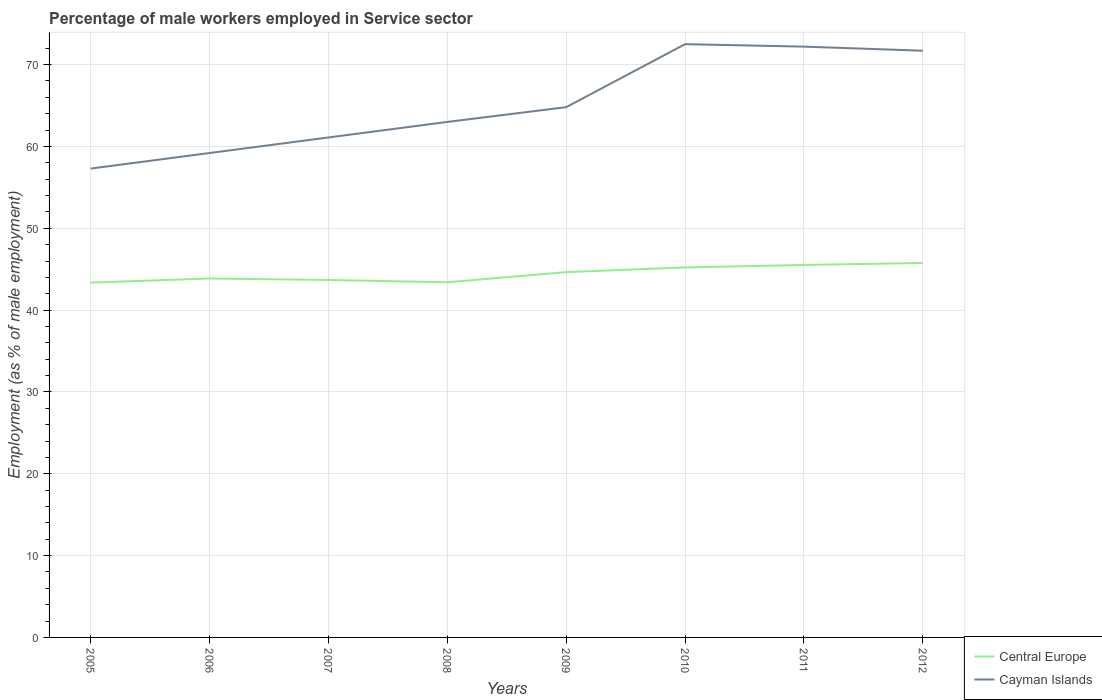How many different coloured lines are there?
Offer a terse response. 2. Does the line corresponding to Cayman Islands intersect with the line corresponding to Central Europe?
Make the answer very short. No. Is the number of lines equal to the number of legend labels?
Provide a succinct answer. Yes. Across all years, what is the maximum percentage of male workers employed in Service sector in Central Europe?
Ensure brevity in your answer.  43.36. What is the total percentage of male workers employed in Service sector in Cayman Islands in the graph?
Provide a short and direct response. -14.4. What is the difference between the highest and the second highest percentage of male workers employed in Service sector in Central Europe?
Offer a terse response. 2.4. Is the percentage of male workers employed in Service sector in Central Europe strictly greater than the percentage of male workers employed in Service sector in Cayman Islands over the years?
Offer a very short reply. Yes. How many years are there in the graph?
Your answer should be very brief. 8. Are the values on the major ticks of Y-axis written in scientific E-notation?
Give a very brief answer. No. How many legend labels are there?
Offer a terse response. 2. What is the title of the graph?
Offer a terse response. Percentage of male workers employed in Service sector. Does "Nepal" appear as one of the legend labels in the graph?
Your answer should be very brief. No. What is the label or title of the X-axis?
Make the answer very short. Years. What is the label or title of the Y-axis?
Offer a very short reply. Employment (as % of male employment). What is the Employment (as % of male employment) in Central Europe in 2005?
Keep it short and to the point. 43.36. What is the Employment (as % of male employment) of Cayman Islands in 2005?
Your response must be concise. 57.3. What is the Employment (as % of male employment) of Central Europe in 2006?
Provide a short and direct response. 43.87. What is the Employment (as % of male employment) in Cayman Islands in 2006?
Provide a succinct answer. 59.2. What is the Employment (as % of male employment) of Central Europe in 2007?
Offer a very short reply. 43.68. What is the Employment (as % of male employment) of Cayman Islands in 2007?
Keep it short and to the point. 61.1. What is the Employment (as % of male employment) of Central Europe in 2008?
Keep it short and to the point. 43.4. What is the Employment (as % of male employment) of Central Europe in 2009?
Your answer should be very brief. 44.64. What is the Employment (as % of male employment) in Cayman Islands in 2009?
Provide a short and direct response. 64.8. What is the Employment (as % of male employment) of Central Europe in 2010?
Your answer should be compact. 45.22. What is the Employment (as % of male employment) in Cayman Islands in 2010?
Provide a short and direct response. 72.5. What is the Employment (as % of male employment) in Central Europe in 2011?
Offer a terse response. 45.52. What is the Employment (as % of male employment) in Cayman Islands in 2011?
Give a very brief answer. 72.2. What is the Employment (as % of male employment) in Central Europe in 2012?
Your answer should be very brief. 45.76. What is the Employment (as % of male employment) in Cayman Islands in 2012?
Offer a terse response. 71.7. Across all years, what is the maximum Employment (as % of male employment) in Central Europe?
Give a very brief answer. 45.76. Across all years, what is the maximum Employment (as % of male employment) of Cayman Islands?
Your response must be concise. 72.5. Across all years, what is the minimum Employment (as % of male employment) in Central Europe?
Give a very brief answer. 43.36. Across all years, what is the minimum Employment (as % of male employment) in Cayman Islands?
Offer a very short reply. 57.3. What is the total Employment (as % of male employment) of Central Europe in the graph?
Your answer should be very brief. 355.45. What is the total Employment (as % of male employment) of Cayman Islands in the graph?
Your answer should be very brief. 521.8. What is the difference between the Employment (as % of male employment) of Central Europe in 2005 and that in 2006?
Your answer should be very brief. -0.51. What is the difference between the Employment (as % of male employment) of Central Europe in 2005 and that in 2007?
Provide a succinct answer. -0.33. What is the difference between the Employment (as % of male employment) of Central Europe in 2005 and that in 2008?
Ensure brevity in your answer.  -0.04. What is the difference between the Employment (as % of male employment) in Central Europe in 2005 and that in 2009?
Provide a succinct answer. -1.28. What is the difference between the Employment (as % of male employment) in Central Europe in 2005 and that in 2010?
Offer a terse response. -1.86. What is the difference between the Employment (as % of male employment) of Cayman Islands in 2005 and that in 2010?
Your answer should be compact. -15.2. What is the difference between the Employment (as % of male employment) in Central Europe in 2005 and that in 2011?
Your answer should be compact. -2.16. What is the difference between the Employment (as % of male employment) of Cayman Islands in 2005 and that in 2011?
Your answer should be very brief. -14.9. What is the difference between the Employment (as % of male employment) in Central Europe in 2005 and that in 2012?
Offer a very short reply. -2.4. What is the difference between the Employment (as % of male employment) in Cayman Islands in 2005 and that in 2012?
Ensure brevity in your answer.  -14.4. What is the difference between the Employment (as % of male employment) of Central Europe in 2006 and that in 2007?
Offer a terse response. 0.18. What is the difference between the Employment (as % of male employment) in Cayman Islands in 2006 and that in 2007?
Keep it short and to the point. -1.9. What is the difference between the Employment (as % of male employment) of Central Europe in 2006 and that in 2008?
Your answer should be compact. 0.46. What is the difference between the Employment (as % of male employment) in Central Europe in 2006 and that in 2009?
Your answer should be very brief. -0.78. What is the difference between the Employment (as % of male employment) of Cayman Islands in 2006 and that in 2009?
Offer a very short reply. -5.6. What is the difference between the Employment (as % of male employment) in Central Europe in 2006 and that in 2010?
Keep it short and to the point. -1.35. What is the difference between the Employment (as % of male employment) in Central Europe in 2006 and that in 2011?
Offer a very short reply. -1.65. What is the difference between the Employment (as % of male employment) in Cayman Islands in 2006 and that in 2011?
Your answer should be compact. -13. What is the difference between the Employment (as % of male employment) of Central Europe in 2006 and that in 2012?
Provide a short and direct response. -1.89. What is the difference between the Employment (as % of male employment) of Cayman Islands in 2006 and that in 2012?
Provide a short and direct response. -12.5. What is the difference between the Employment (as % of male employment) of Central Europe in 2007 and that in 2008?
Make the answer very short. 0.28. What is the difference between the Employment (as % of male employment) of Cayman Islands in 2007 and that in 2008?
Provide a succinct answer. -1.9. What is the difference between the Employment (as % of male employment) of Central Europe in 2007 and that in 2009?
Provide a short and direct response. -0.96. What is the difference between the Employment (as % of male employment) in Central Europe in 2007 and that in 2010?
Your answer should be very brief. -1.53. What is the difference between the Employment (as % of male employment) in Cayman Islands in 2007 and that in 2010?
Provide a short and direct response. -11.4. What is the difference between the Employment (as % of male employment) of Central Europe in 2007 and that in 2011?
Ensure brevity in your answer.  -1.84. What is the difference between the Employment (as % of male employment) of Cayman Islands in 2007 and that in 2011?
Your answer should be compact. -11.1. What is the difference between the Employment (as % of male employment) in Central Europe in 2007 and that in 2012?
Offer a very short reply. -2.08. What is the difference between the Employment (as % of male employment) of Central Europe in 2008 and that in 2009?
Offer a terse response. -1.24. What is the difference between the Employment (as % of male employment) in Cayman Islands in 2008 and that in 2009?
Offer a very short reply. -1.8. What is the difference between the Employment (as % of male employment) in Central Europe in 2008 and that in 2010?
Give a very brief answer. -1.81. What is the difference between the Employment (as % of male employment) of Cayman Islands in 2008 and that in 2010?
Ensure brevity in your answer.  -9.5. What is the difference between the Employment (as % of male employment) in Central Europe in 2008 and that in 2011?
Make the answer very short. -2.12. What is the difference between the Employment (as % of male employment) in Central Europe in 2008 and that in 2012?
Keep it short and to the point. -2.36. What is the difference between the Employment (as % of male employment) in Cayman Islands in 2008 and that in 2012?
Make the answer very short. -8.7. What is the difference between the Employment (as % of male employment) of Central Europe in 2009 and that in 2010?
Keep it short and to the point. -0.57. What is the difference between the Employment (as % of male employment) in Cayman Islands in 2009 and that in 2010?
Provide a short and direct response. -7.7. What is the difference between the Employment (as % of male employment) of Central Europe in 2009 and that in 2011?
Give a very brief answer. -0.88. What is the difference between the Employment (as % of male employment) in Cayman Islands in 2009 and that in 2011?
Ensure brevity in your answer.  -7.4. What is the difference between the Employment (as % of male employment) in Central Europe in 2009 and that in 2012?
Make the answer very short. -1.12. What is the difference between the Employment (as % of male employment) in Cayman Islands in 2009 and that in 2012?
Your response must be concise. -6.9. What is the difference between the Employment (as % of male employment) in Central Europe in 2010 and that in 2011?
Your response must be concise. -0.3. What is the difference between the Employment (as % of male employment) of Cayman Islands in 2010 and that in 2011?
Ensure brevity in your answer.  0.3. What is the difference between the Employment (as % of male employment) in Central Europe in 2010 and that in 2012?
Offer a terse response. -0.54. What is the difference between the Employment (as % of male employment) in Cayman Islands in 2010 and that in 2012?
Offer a very short reply. 0.8. What is the difference between the Employment (as % of male employment) of Central Europe in 2011 and that in 2012?
Provide a succinct answer. -0.24. What is the difference between the Employment (as % of male employment) in Central Europe in 2005 and the Employment (as % of male employment) in Cayman Islands in 2006?
Offer a terse response. -15.84. What is the difference between the Employment (as % of male employment) in Central Europe in 2005 and the Employment (as % of male employment) in Cayman Islands in 2007?
Provide a succinct answer. -17.74. What is the difference between the Employment (as % of male employment) in Central Europe in 2005 and the Employment (as % of male employment) in Cayman Islands in 2008?
Offer a terse response. -19.64. What is the difference between the Employment (as % of male employment) in Central Europe in 2005 and the Employment (as % of male employment) in Cayman Islands in 2009?
Provide a succinct answer. -21.44. What is the difference between the Employment (as % of male employment) in Central Europe in 2005 and the Employment (as % of male employment) in Cayman Islands in 2010?
Provide a short and direct response. -29.14. What is the difference between the Employment (as % of male employment) in Central Europe in 2005 and the Employment (as % of male employment) in Cayman Islands in 2011?
Your answer should be very brief. -28.84. What is the difference between the Employment (as % of male employment) of Central Europe in 2005 and the Employment (as % of male employment) of Cayman Islands in 2012?
Your response must be concise. -28.34. What is the difference between the Employment (as % of male employment) of Central Europe in 2006 and the Employment (as % of male employment) of Cayman Islands in 2007?
Provide a succinct answer. -17.23. What is the difference between the Employment (as % of male employment) in Central Europe in 2006 and the Employment (as % of male employment) in Cayman Islands in 2008?
Provide a short and direct response. -19.13. What is the difference between the Employment (as % of male employment) of Central Europe in 2006 and the Employment (as % of male employment) of Cayman Islands in 2009?
Make the answer very short. -20.93. What is the difference between the Employment (as % of male employment) in Central Europe in 2006 and the Employment (as % of male employment) in Cayman Islands in 2010?
Make the answer very short. -28.63. What is the difference between the Employment (as % of male employment) of Central Europe in 2006 and the Employment (as % of male employment) of Cayman Islands in 2011?
Your answer should be compact. -28.33. What is the difference between the Employment (as % of male employment) of Central Europe in 2006 and the Employment (as % of male employment) of Cayman Islands in 2012?
Your answer should be compact. -27.83. What is the difference between the Employment (as % of male employment) of Central Europe in 2007 and the Employment (as % of male employment) of Cayman Islands in 2008?
Provide a succinct answer. -19.32. What is the difference between the Employment (as % of male employment) in Central Europe in 2007 and the Employment (as % of male employment) in Cayman Islands in 2009?
Give a very brief answer. -21.12. What is the difference between the Employment (as % of male employment) of Central Europe in 2007 and the Employment (as % of male employment) of Cayman Islands in 2010?
Offer a terse response. -28.82. What is the difference between the Employment (as % of male employment) of Central Europe in 2007 and the Employment (as % of male employment) of Cayman Islands in 2011?
Offer a very short reply. -28.52. What is the difference between the Employment (as % of male employment) in Central Europe in 2007 and the Employment (as % of male employment) in Cayman Islands in 2012?
Provide a succinct answer. -28.02. What is the difference between the Employment (as % of male employment) of Central Europe in 2008 and the Employment (as % of male employment) of Cayman Islands in 2009?
Ensure brevity in your answer.  -21.4. What is the difference between the Employment (as % of male employment) of Central Europe in 2008 and the Employment (as % of male employment) of Cayman Islands in 2010?
Your response must be concise. -29.1. What is the difference between the Employment (as % of male employment) of Central Europe in 2008 and the Employment (as % of male employment) of Cayman Islands in 2011?
Your answer should be very brief. -28.8. What is the difference between the Employment (as % of male employment) of Central Europe in 2008 and the Employment (as % of male employment) of Cayman Islands in 2012?
Give a very brief answer. -28.3. What is the difference between the Employment (as % of male employment) of Central Europe in 2009 and the Employment (as % of male employment) of Cayman Islands in 2010?
Your answer should be very brief. -27.86. What is the difference between the Employment (as % of male employment) in Central Europe in 2009 and the Employment (as % of male employment) in Cayman Islands in 2011?
Your answer should be compact. -27.56. What is the difference between the Employment (as % of male employment) in Central Europe in 2009 and the Employment (as % of male employment) in Cayman Islands in 2012?
Offer a terse response. -27.06. What is the difference between the Employment (as % of male employment) in Central Europe in 2010 and the Employment (as % of male employment) in Cayman Islands in 2011?
Offer a very short reply. -26.98. What is the difference between the Employment (as % of male employment) of Central Europe in 2010 and the Employment (as % of male employment) of Cayman Islands in 2012?
Keep it short and to the point. -26.48. What is the difference between the Employment (as % of male employment) of Central Europe in 2011 and the Employment (as % of male employment) of Cayman Islands in 2012?
Give a very brief answer. -26.18. What is the average Employment (as % of male employment) in Central Europe per year?
Your answer should be compact. 44.43. What is the average Employment (as % of male employment) of Cayman Islands per year?
Ensure brevity in your answer.  65.22. In the year 2005, what is the difference between the Employment (as % of male employment) of Central Europe and Employment (as % of male employment) of Cayman Islands?
Your answer should be very brief. -13.94. In the year 2006, what is the difference between the Employment (as % of male employment) in Central Europe and Employment (as % of male employment) in Cayman Islands?
Your response must be concise. -15.33. In the year 2007, what is the difference between the Employment (as % of male employment) in Central Europe and Employment (as % of male employment) in Cayman Islands?
Offer a terse response. -17.42. In the year 2008, what is the difference between the Employment (as % of male employment) in Central Europe and Employment (as % of male employment) in Cayman Islands?
Make the answer very short. -19.6. In the year 2009, what is the difference between the Employment (as % of male employment) of Central Europe and Employment (as % of male employment) of Cayman Islands?
Provide a short and direct response. -20.16. In the year 2010, what is the difference between the Employment (as % of male employment) in Central Europe and Employment (as % of male employment) in Cayman Islands?
Keep it short and to the point. -27.28. In the year 2011, what is the difference between the Employment (as % of male employment) in Central Europe and Employment (as % of male employment) in Cayman Islands?
Keep it short and to the point. -26.68. In the year 2012, what is the difference between the Employment (as % of male employment) in Central Europe and Employment (as % of male employment) in Cayman Islands?
Offer a terse response. -25.94. What is the ratio of the Employment (as % of male employment) of Central Europe in 2005 to that in 2006?
Your answer should be very brief. 0.99. What is the ratio of the Employment (as % of male employment) of Cayman Islands in 2005 to that in 2006?
Offer a very short reply. 0.97. What is the ratio of the Employment (as % of male employment) of Central Europe in 2005 to that in 2007?
Offer a terse response. 0.99. What is the ratio of the Employment (as % of male employment) of Cayman Islands in 2005 to that in 2007?
Keep it short and to the point. 0.94. What is the ratio of the Employment (as % of male employment) in Cayman Islands in 2005 to that in 2008?
Ensure brevity in your answer.  0.91. What is the ratio of the Employment (as % of male employment) in Central Europe in 2005 to that in 2009?
Ensure brevity in your answer.  0.97. What is the ratio of the Employment (as % of male employment) of Cayman Islands in 2005 to that in 2009?
Provide a succinct answer. 0.88. What is the ratio of the Employment (as % of male employment) in Central Europe in 2005 to that in 2010?
Your response must be concise. 0.96. What is the ratio of the Employment (as % of male employment) in Cayman Islands in 2005 to that in 2010?
Make the answer very short. 0.79. What is the ratio of the Employment (as % of male employment) in Central Europe in 2005 to that in 2011?
Provide a succinct answer. 0.95. What is the ratio of the Employment (as % of male employment) in Cayman Islands in 2005 to that in 2011?
Provide a short and direct response. 0.79. What is the ratio of the Employment (as % of male employment) in Central Europe in 2005 to that in 2012?
Your answer should be very brief. 0.95. What is the ratio of the Employment (as % of male employment) in Cayman Islands in 2005 to that in 2012?
Offer a very short reply. 0.8. What is the ratio of the Employment (as % of male employment) of Central Europe in 2006 to that in 2007?
Provide a succinct answer. 1. What is the ratio of the Employment (as % of male employment) in Cayman Islands in 2006 to that in 2007?
Make the answer very short. 0.97. What is the ratio of the Employment (as % of male employment) in Central Europe in 2006 to that in 2008?
Ensure brevity in your answer.  1.01. What is the ratio of the Employment (as % of male employment) in Cayman Islands in 2006 to that in 2008?
Your answer should be very brief. 0.94. What is the ratio of the Employment (as % of male employment) in Central Europe in 2006 to that in 2009?
Offer a very short reply. 0.98. What is the ratio of the Employment (as % of male employment) of Cayman Islands in 2006 to that in 2009?
Your answer should be very brief. 0.91. What is the ratio of the Employment (as % of male employment) of Central Europe in 2006 to that in 2010?
Your response must be concise. 0.97. What is the ratio of the Employment (as % of male employment) in Cayman Islands in 2006 to that in 2010?
Provide a succinct answer. 0.82. What is the ratio of the Employment (as % of male employment) in Central Europe in 2006 to that in 2011?
Ensure brevity in your answer.  0.96. What is the ratio of the Employment (as % of male employment) in Cayman Islands in 2006 to that in 2011?
Make the answer very short. 0.82. What is the ratio of the Employment (as % of male employment) in Central Europe in 2006 to that in 2012?
Keep it short and to the point. 0.96. What is the ratio of the Employment (as % of male employment) of Cayman Islands in 2006 to that in 2012?
Give a very brief answer. 0.83. What is the ratio of the Employment (as % of male employment) of Central Europe in 2007 to that in 2008?
Ensure brevity in your answer.  1.01. What is the ratio of the Employment (as % of male employment) in Cayman Islands in 2007 to that in 2008?
Your answer should be compact. 0.97. What is the ratio of the Employment (as % of male employment) of Central Europe in 2007 to that in 2009?
Make the answer very short. 0.98. What is the ratio of the Employment (as % of male employment) of Cayman Islands in 2007 to that in 2009?
Your answer should be compact. 0.94. What is the ratio of the Employment (as % of male employment) in Central Europe in 2007 to that in 2010?
Offer a terse response. 0.97. What is the ratio of the Employment (as % of male employment) of Cayman Islands in 2007 to that in 2010?
Your answer should be very brief. 0.84. What is the ratio of the Employment (as % of male employment) in Central Europe in 2007 to that in 2011?
Your response must be concise. 0.96. What is the ratio of the Employment (as % of male employment) in Cayman Islands in 2007 to that in 2011?
Provide a short and direct response. 0.85. What is the ratio of the Employment (as % of male employment) in Central Europe in 2007 to that in 2012?
Your answer should be compact. 0.95. What is the ratio of the Employment (as % of male employment) in Cayman Islands in 2007 to that in 2012?
Offer a terse response. 0.85. What is the ratio of the Employment (as % of male employment) of Central Europe in 2008 to that in 2009?
Ensure brevity in your answer.  0.97. What is the ratio of the Employment (as % of male employment) of Cayman Islands in 2008 to that in 2009?
Your answer should be compact. 0.97. What is the ratio of the Employment (as % of male employment) in Central Europe in 2008 to that in 2010?
Keep it short and to the point. 0.96. What is the ratio of the Employment (as % of male employment) in Cayman Islands in 2008 to that in 2010?
Give a very brief answer. 0.87. What is the ratio of the Employment (as % of male employment) in Central Europe in 2008 to that in 2011?
Offer a terse response. 0.95. What is the ratio of the Employment (as % of male employment) of Cayman Islands in 2008 to that in 2011?
Offer a terse response. 0.87. What is the ratio of the Employment (as % of male employment) of Central Europe in 2008 to that in 2012?
Offer a very short reply. 0.95. What is the ratio of the Employment (as % of male employment) of Cayman Islands in 2008 to that in 2012?
Offer a very short reply. 0.88. What is the ratio of the Employment (as % of male employment) in Central Europe in 2009 to that in 2010?
Your answer should be compact. 0.99. What is the ratio of the Employment (as % of male employment) in Cayman Islands in 2009 to that in 2010?
Keep it short and to the point. 0.89. What is the ratio of the Employment (as % of male employment) in Central Europe in 2009 to that in 2011?
Ensure brevity in your answer.  0.98. What is the ratio of the Employment (as % of male employment) in Cayman Islands in 2009 to that in 2011?
Offer a terse response. 0.9. What is the ratio of the Employment (as % of male employment) of Central Europe in 2009 to that in 2012?
Ensure brevity in your answer.  0.98. What is the ratio of the Employment (as % of male employment) of Cayman Islands in 2009 to that in 2012?
Provide a short and direct response. 0.9. What is the ratio of the Employment (as % of male employment) in Central Europe in 2010 to that in 2011?
Keep it short and to the point. 0.99. What is the ratio of the Employment (as % of male employment) in Central Europe in 2010 to that in 2012?
Provide a short and direct response. 0.99. What is the ratio of the Employment (as % of male employment) in Cayman Islands in 2010 to that in 2012?
Ensure brevity in your answer.  1.01. What is the ratio of the Employment (as % of male employment) of Central Europe in 2011 to that in 2012?
Keep it short and to the point. 0.99. What is the difference between the highest and the second highest Employment (as % of male employment) of Central Europe?
Your response must be concise. 0.24. What is the difference between the highest and the lowest Employment (as % of male employment) in Central Europe?
Ensure brevity in your answer.  2.4. 